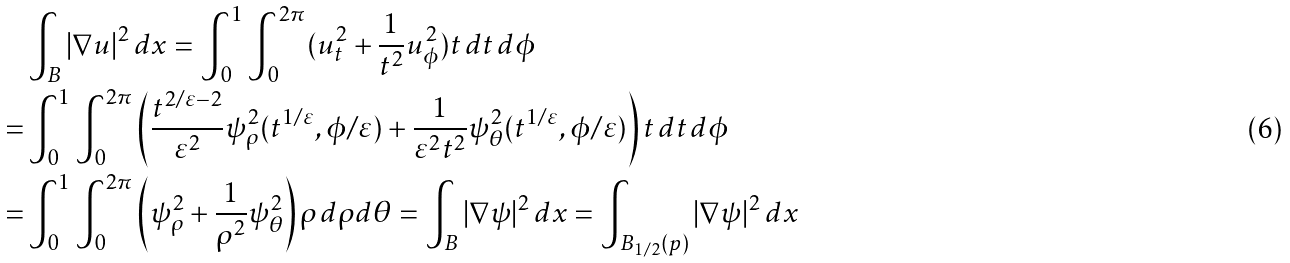<formula> <loc_0><loc_0><loc_500><loc_500>& \int _ { B } | \nabla u | ^ { 2 } \, d x = \int _ { 0 } ^ { 1 } \int _ { 0 } ^ { 2 \pi } ( u _ { t } ^ { 2 } + \frac { 1 } { t ^ { 2 } } u _ { \phi } ^ { 2 } ) t \, d t \, d \phi \\ = & \int _ { 0 } ^ { 1 } \int _ { 0 } ^ { 2 \pi } \left ( \frac { t ^ { 2 / \varepsilon - 2 } } { \varepsilon ^ { 2 } } \psi _ { \rho } ^ { 2 } ( t ^ { 1 / \varepsilon } , \phi / \varepsilon ) + \frac { 1 } { \varepsilon ^ { 2 } t ^ { 2 } } \psi _ { \theta } ^ { 2 } ( t ^ { 1 / \varepsilon } , \phi / \varepsilon ) \right ) t \, d t \, d \phi \\ = & \int _ { 0 } ^ { 1 } \int _ { 0 } ^ { 2 \pi } \left ( \psi _ { \rho } ^ { 2 } + \frac { 1 } { \rho ^ { 2 } } \psi _ { \theta } ^ { 2 } \right ) \rho \, d \rho d \theta = \int _ { B } | \nabla \psi | ^ { 2 } \, d x = \int _ { B _ { 1 / 2 } ( p ) } | \nabla \psi | ^ { 2 } \, d x</formula> 